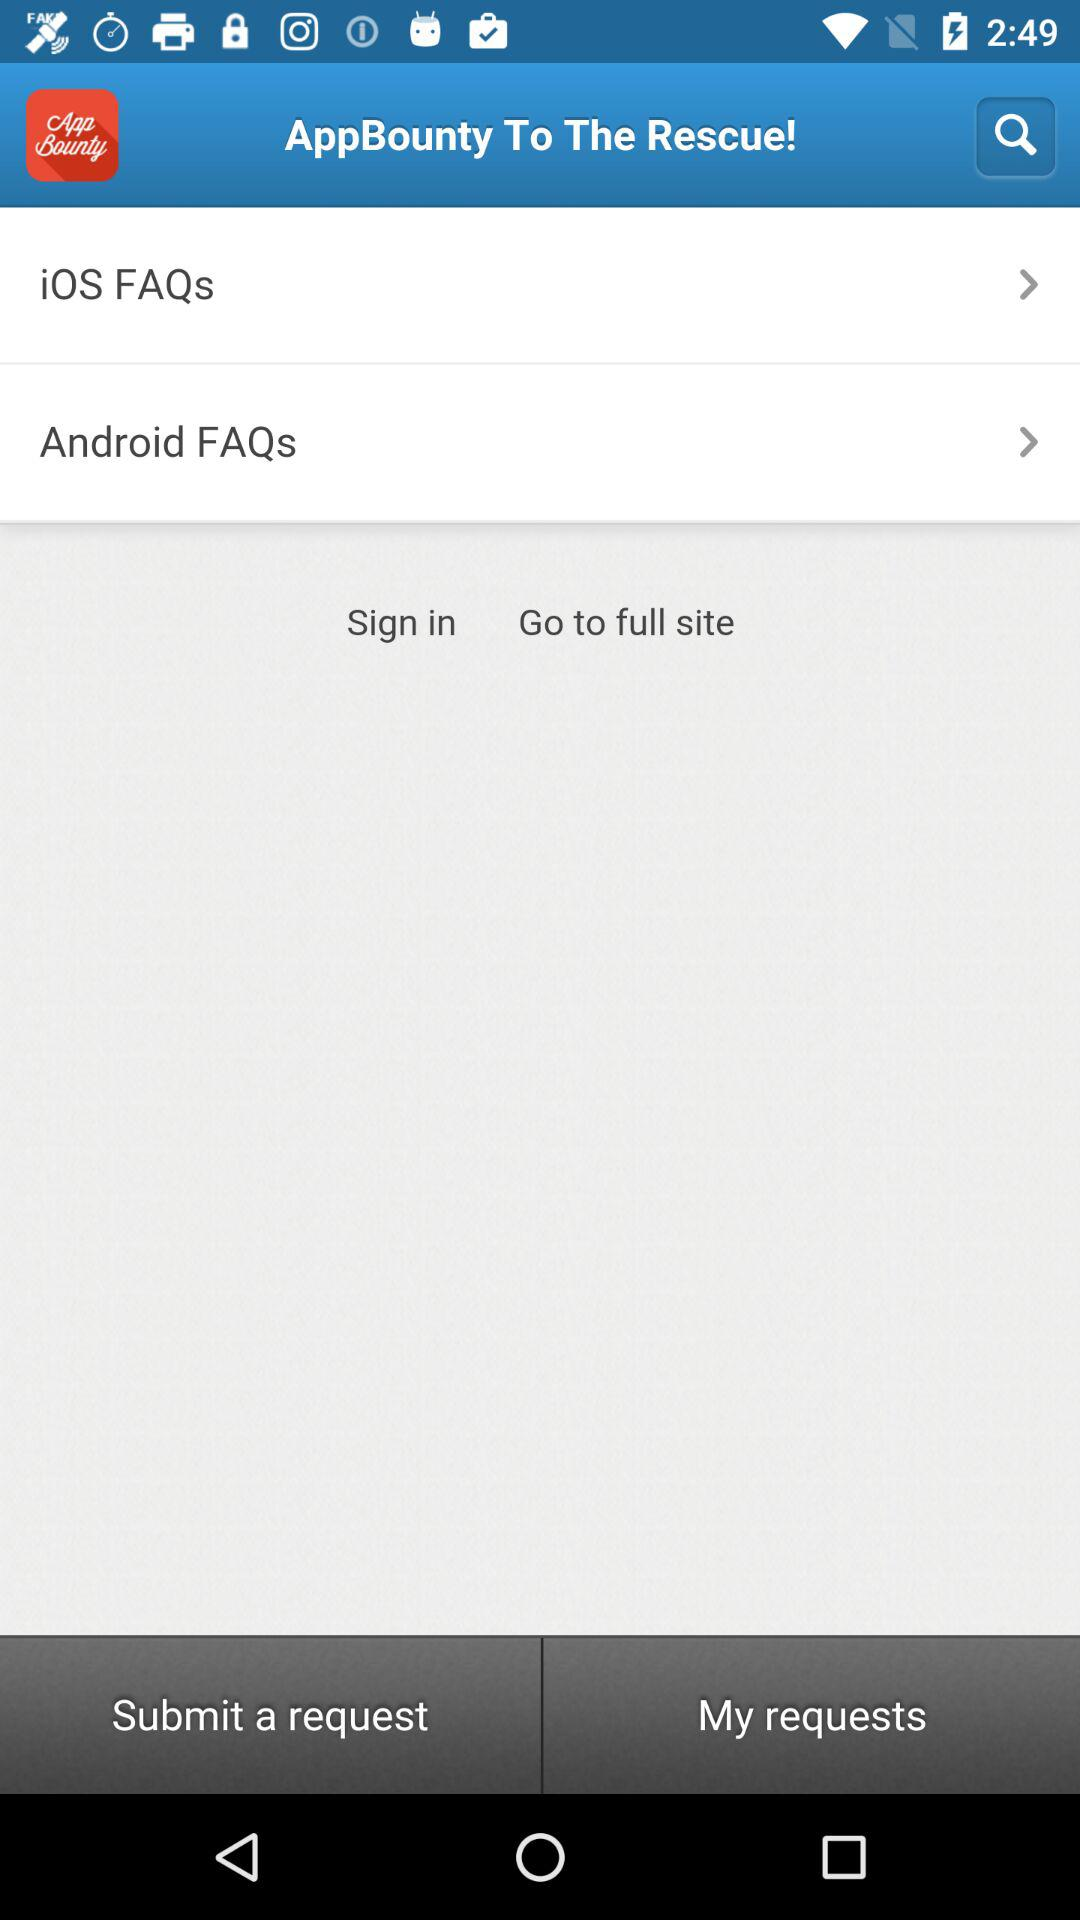What is the name of the application? The name of the application is "AppBounty". 